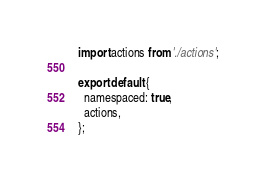Convert code to text. <code><loc_0><loc_0><loc_500><loc_500><_JavaScript_>import actions from './actions';

export default {
  namespaced: true,
  actions,
};
</code> 